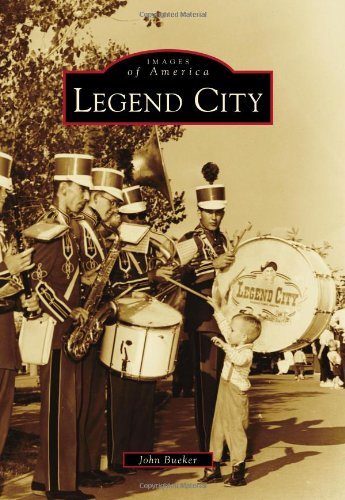What type of book is this? The book is best described as a non-fiction historical account that uses imagery and narrative to explore the chronicles of Legend City, a theme park based in America, capturing its societal and cultural impact. 